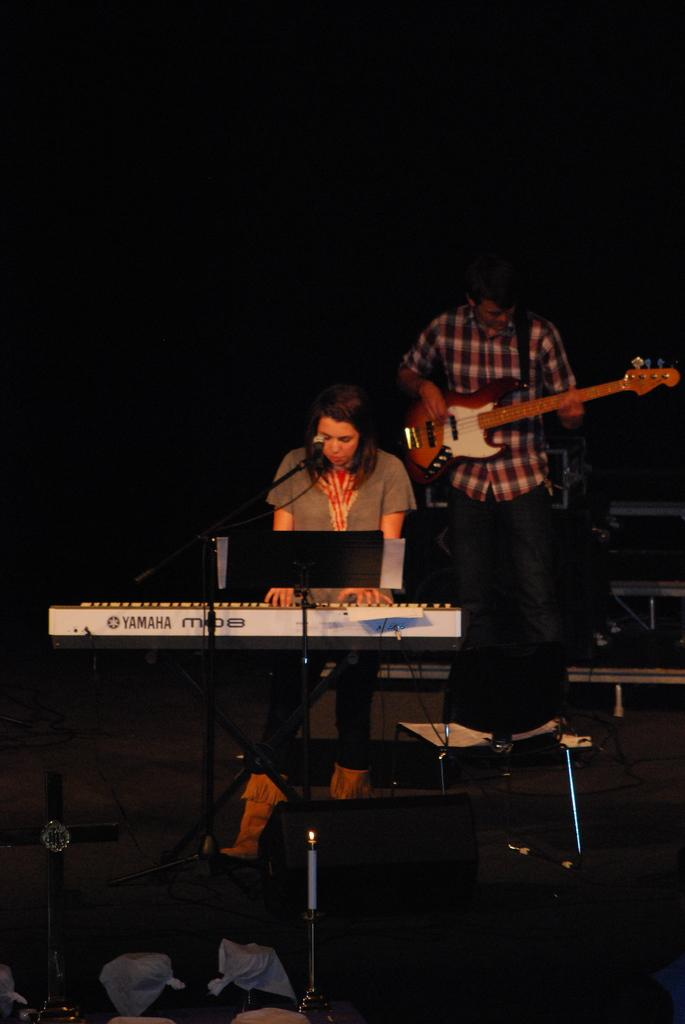What is the woman in the image doing? The woman is playing a piano. Can you describe the musical instruments being played in the image? The woman is playing a piano, and there is a man in the background playing a guitar. What is the gender of the person playing the guitar? The person playing the guitar is a man. What is the name of the lawyer who is fighting in the image? There is no lawyer or fight present in the image; it features a woman playing a piano and a man playing a guitar. 